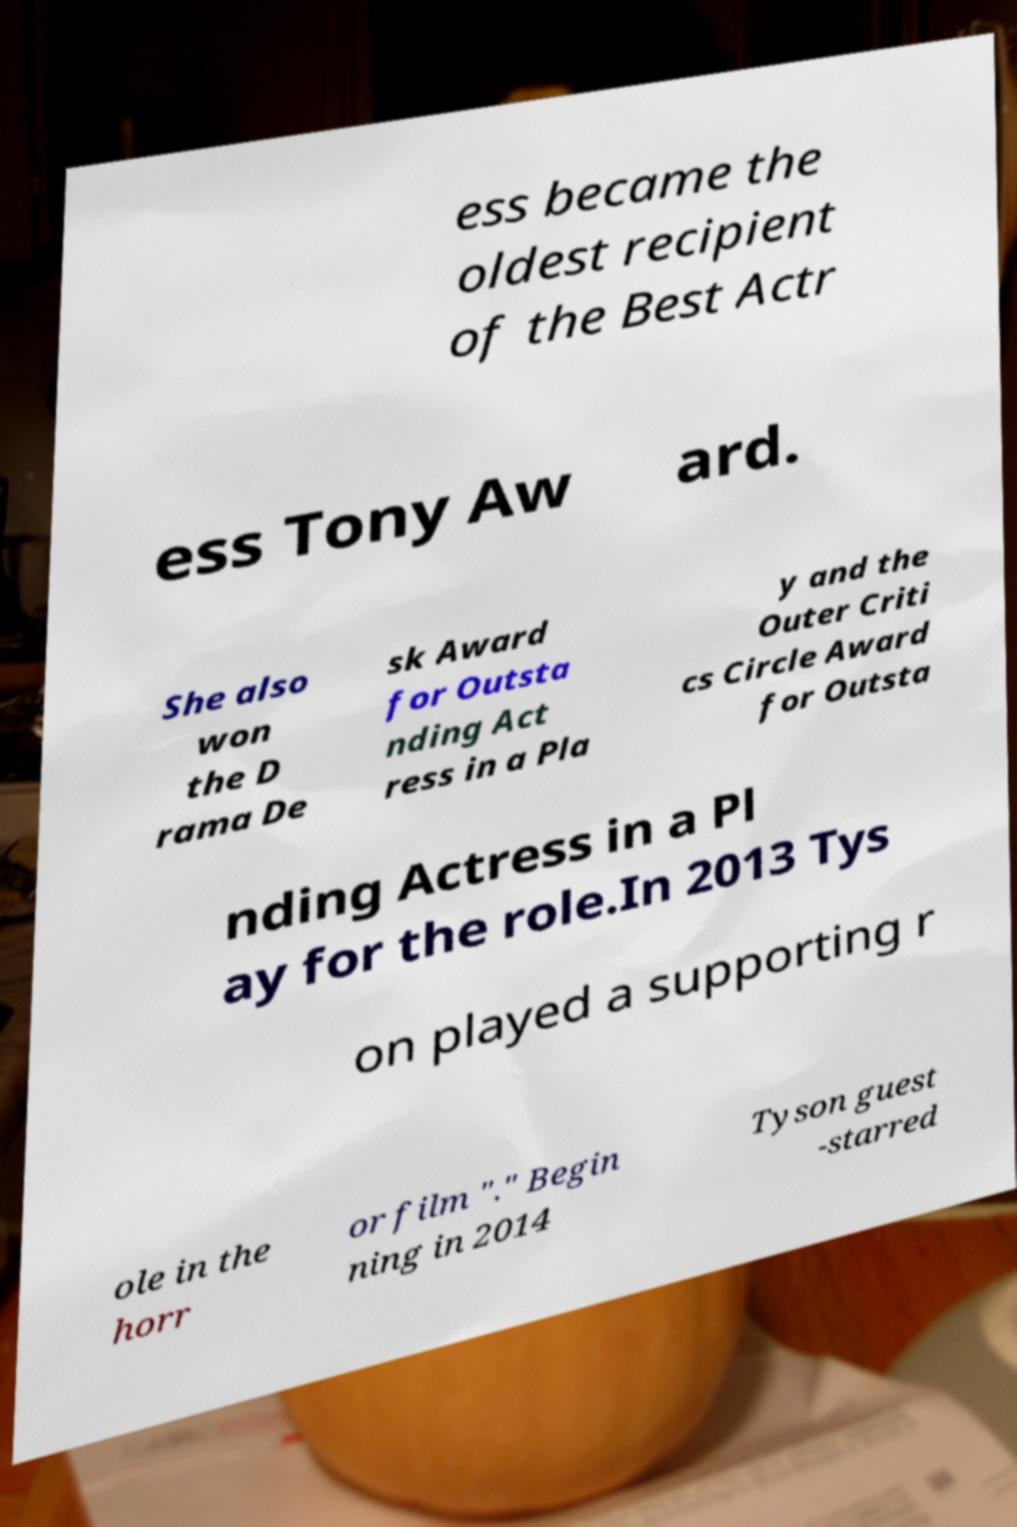Please read and relay the text visible in this image. What does it say? ess became the oldest recipient of the Best Actr ess Tony Aw ard. She also won the D rama De sk Award for Outsta nding Act ress in a Pla y and the Outer Criti cs Circle Award for Outsta nding Actress in a Pl ay for the role.In 2013 Tys on played a supporting r ole in the horr or film "." Begin ning in 2014 Tyson guest -starred 